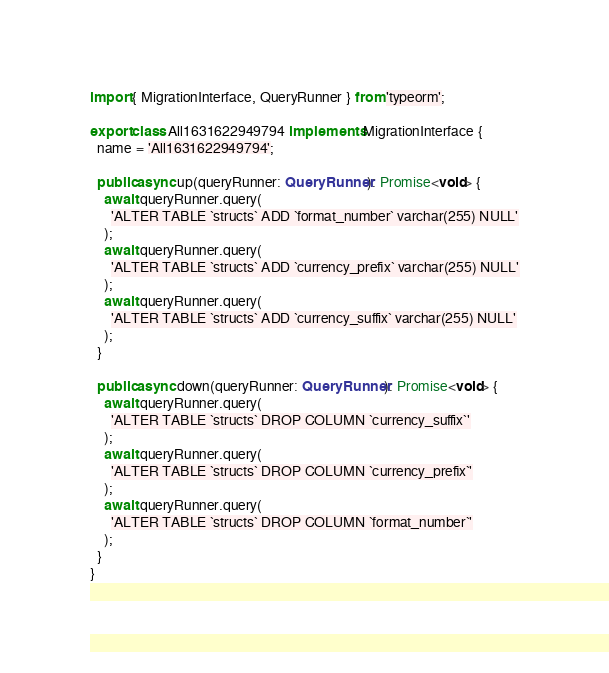<code> <loc_0><loc_0><loc_500><loc_500><_TypeScript_>import { MigrationInterface, QueryRunner } from 'typeorm';

export class All1631622949794 implements MigrationInterface {
  name = 'All1631622949794';

  public async up(queryRunner: QueryRunner): Promise<void> {
    await queryRunner.query(
      'ALTER TABLE `structs` ADD `format_number` varchar(255) NULL'
    );
    await queryRunner.query(
      'ALTER TABLE `structs` ADD `currency_prefix` varchar(255) NULL'
    );
    await queryRunner.query(
      'ALTER TABLE `structs` ADD `currency_suffix` varchar(255) NULL'
    );
  }

  public async down(queryRunner: QueryRunner): Promise<void> {
    await queryRunner.query(
      'ALTER TABLE `structs` DROP COLUMN `currency_suffix`'
    );
    await queryRunner.query(
      'ALTER TABLE `structs` DROP COLUMN `currency_prefix`'
    );
    await queryRunner.query(
      'ALTER TABLE `structs` DROP COLUMN `format_number`'
    );
  }
}
</code> 